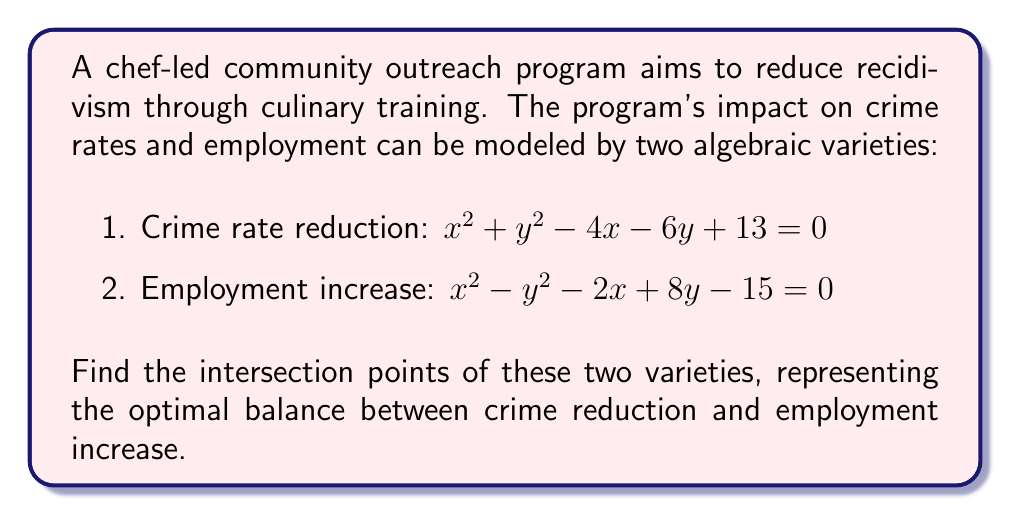Help me with this question. To find the intersection points, we need to solve the system of equations:

$$\begin{cases}
x^2 + y^2 - 4x - 6y + 13 = 0 \quad (1)\\
x^2 - y^2 - 2x + 8y - 15 = 0 \quad (2)
\end{cases}$$

Step 1: Subtract equation (2) from equation (1)
$$(x^2 + y^2 - 4x - 6y + 13) - (x^2 - y^2 - 2x + 8y - 15) = 0$$
$$2y^2 - 2x - 14y + 28 = 0$$
$$y^2 - x - 7y + 14 = 0 \quad (3)$$

Step 2: Solve equation (3) for x
$$x = y^2 - 7y + 14 \quad (4)$$

Step 3: Substitute (4) into equation (2)
$$(y^2 - 7y + 14)^2 - y^2 - 2(y^2 - 7y + 14) + 8y - 15 = 0$$

Step 4: Expand and simplify
$$y^4 - 14y^3 + 28y^2 + 49y^2 - 196y + 196 - y^2 - 2y^2 + 14y - 28 + 8y - 15 = 0$$
$$y^4 - 14y^3 + 74y^2 - 174y + 153 = 0$$

Step 5: This is a 4th degree polynomial. We can factor it:
$$(y - 3)(y - 1)(y^2 - 10y + 51) = 0$$

Step 6: Solve for y
$$y = 3 \text{ or } y = 1 \text{ or } y^2 - 10y + 51 = 0$$

The quadratic equation has no real solutions, so we only consider y = 3 and y = 1.

Step 7: Find corresponding x values using equation (4)
For y = 3: x = 3^2 - 7(3) + 14 = 2
For y = 1: x = 1^2 - 7(1) + 14 = 8

Therefore, the intersection points are (2, 3) and (8, 1).
Answer: (2, 3) and (8, 1) 